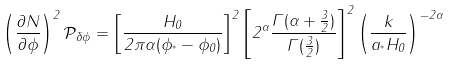Convert formula to latex. <formula><loc_0><loc_0><loc_500><loc_500>\left ( \frac { \partial N } { \partial \phi } \right ) ^ { 2 } \mathcal { P } _ { \delta \phi } = \left [ \frac { H _ { 0 } } { 2 \pi \alpha ( \phi _ { ^ { * } } - \phi _ { 0 } ) } \right ] ^ { 2 } \left [ 2 ^ { \alpha } \frac { \Gamma ( \alpha + \frac { 3 } { 2 } ) } { \Gamma ( \frac { 3 } { 2 } ) } \right ] ^ { 2 } \left ( \frac { k } { a _ { ^ { * } } H _ { 0 } } \right ) ^ { - 2 \alpha }</formula> 